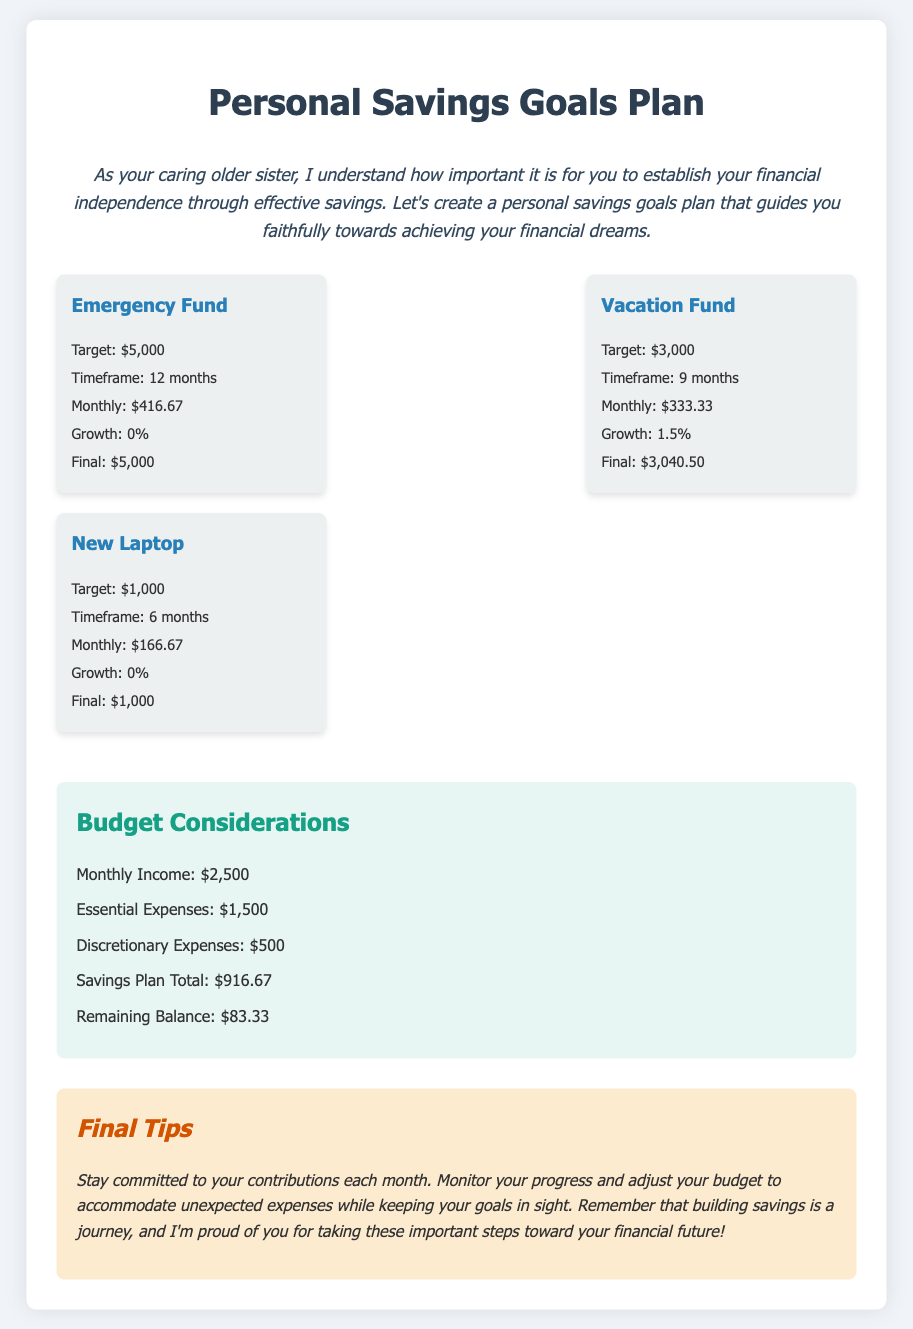What is the target for the Emergency Fund? The target for the Emergency Fund is stated as $5,000 in the document.
Answer: $5,000 How long is the timeframe for the Vacation Fund? The timeframe for the Vacation Fund is given as 9 months.
Answer: 9 months What is the final amount for the New Laptop goal? The final amount for the New Laptop goal is $1,000 as indicated in the document.
Answer: $1,000 What percentage growth is projected for the Vacation Fund? The projected growth for the Vacation Fund is noted as 1.5%.
Answer: 1.5% What is the monthly income mentioned in the budget? The monthly income is mentioned as $2,500 in the budget section of the document.
Answer: $2,500 What is the total amount allocated for the Savings Plan? The total amount allocated for the Savings Plan is $916.67 as indicated under Budget Considerations.
Answer: $916.67 What is the remaining balance after expenses and savings? The remaining balance after expenses and savings is calculated as $83.33.
Answer: $83.33 What should you do if unexpected expenses arise? You should adjust your budget to accommodate unexpected expenses while keeping your goals in sight.
Answer: Adjust your budget What is the purpose of the Personal Savings Goals Plan? The purpose of the plan is to guide you towards achieving your financial dreams through effective savings.
Answer: Financial dreams 